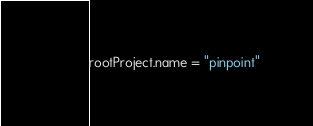<code> <loc_0><loc_0><loc_500><loc_500><_Kotlin_>
rootProject.name = "pinpoint"

</code> 